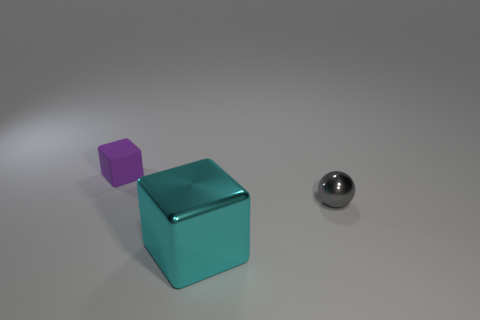Add 1 brown rubber cubes. How many objects exist? 4 Subtract all blocks. How many objects are left? 1 Subtract all purple rubber objects. Subtract all purple cubes. How many objects are left? 1 Add 1 rubber cubes. How many rubber cubes are left? 2 Add 2 cyan objects. How many cyan objects exist? 3 Subtract 0 brown blocks. How many objects are left? 3 